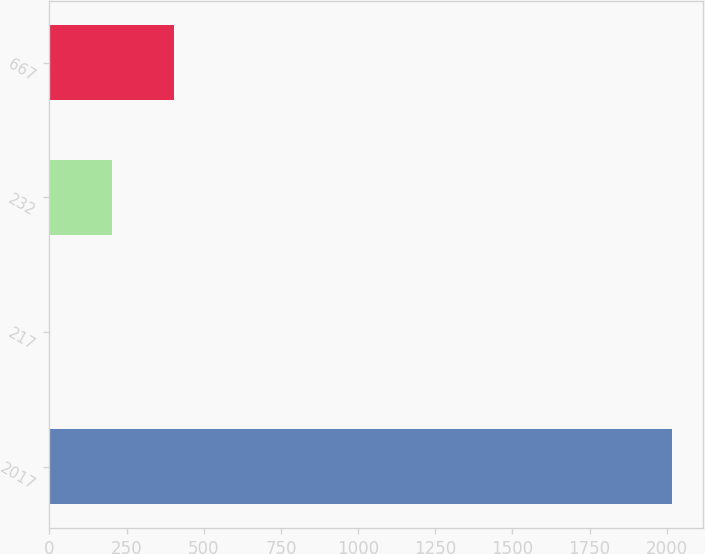Convert chart. <chart><loc_0><loc_0><loc_500><loc_500><bar_chart><fcel>2017<fcel>217<fcel>232<fcel>667<nl><fcel>2016<fcel>2.33<fcel>203.7<fcel>405.07<nl></chart> 